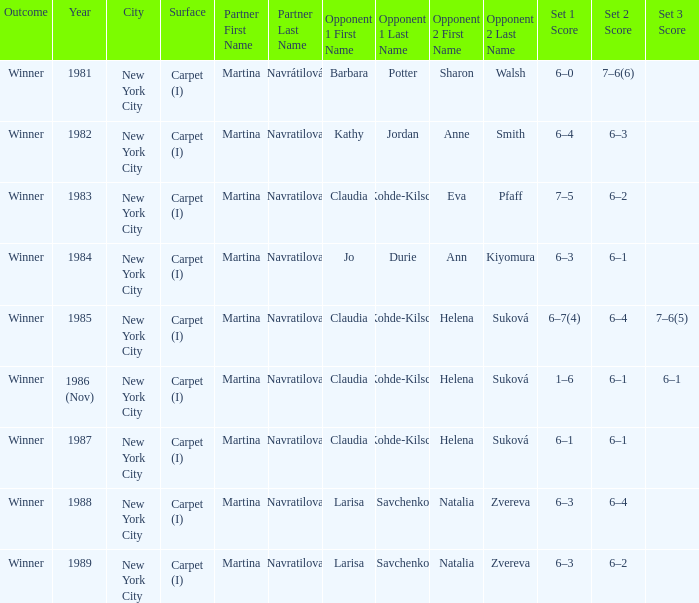How many partners were there in 1988? 1.0. 